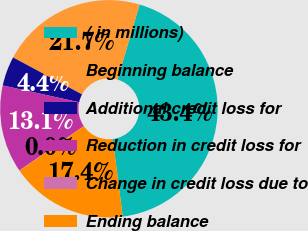Convert chart to OTSL. <chart><loc_0><loc_0><loc_500><loc_500><pie_chart><fcel>( in millions)<fcel>Beginning balance<fcel>Additional credit loss for<fcel>Reduction in credit loss for<fcel>Change in credit loss due to<fcel>Ending balance<nl><fcel>43.41%<fcel>21.73%<fcel>4.38%<fcel>13.05%<fcel>0.04%<fcel>17.39%<nl></chart> 